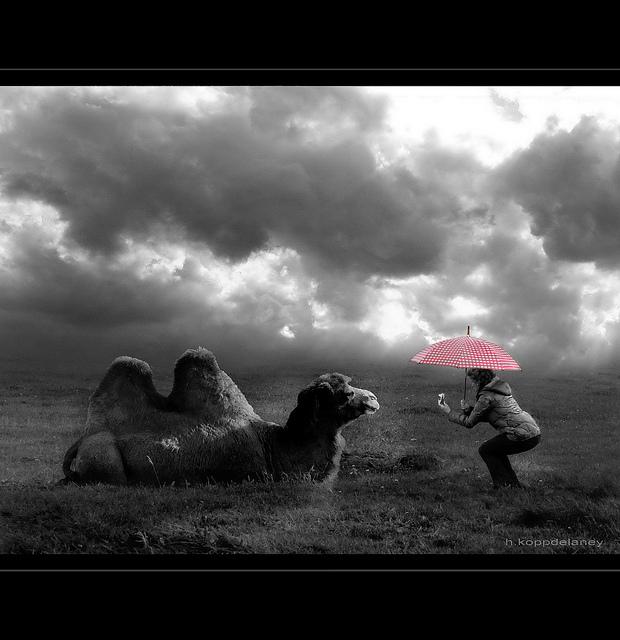Is there one hump or two?
Short answer required. 2. What is the girl trying to do?
Be succinct. Feed camel. What color umbrella is the girl holding?
Concise answer only. Red. 